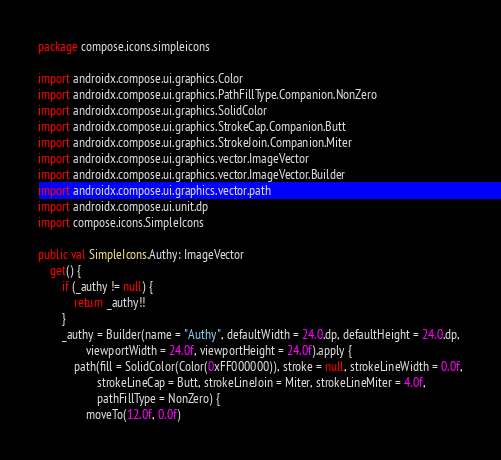Convert code to text. <code><loc_0><loc_0><loc_500><loc_500><_Kotlin_>package compose.icons.simpleicons

import androidx.compose.ui.graphics.Color
import androidx.compose.ui.graphics.PathFillType.Companion.NonZero
import androidx.compose.ui.graphics.SolidColor
import androidx.compose.ui.graphics.StrokeCap.Companion.Butt
import androidx.compose.ui.graphics.StrokeJoin.Companion.Miter
import androidx.compose.ui.graphics.vector.ImageVector
import androidx.compose.ui.graphics.vector.ImageVector.Builder
import androidx.compose.ui.graphics.vector.path
import androidx.compose.ui.unit.dp
import compose.icons.SimpleIcons

public val SimpleIcons.Authy: ImageVector
    get() {
        if (_authy != null) {
            return _authy!!
        }
        _authy = Builder(name = "Authy", defaultWidth = 24.0.dp, defaultHeight = 24.0.dp,
                viewportWidth = 24.0f, viewportHeight = 24.0f).apply {
            path(fill = SolidColor(Color(0xFF000000)), stroke = null, strokeLineWidth = 0.0f,
                    strokeLineCap = Butt, strokeLineJoin = Miter, strokeLineMiter = 4.0f,
                    pathFillType = NonZero) {
                moveTo(12.0f, 0.0f)</code> 